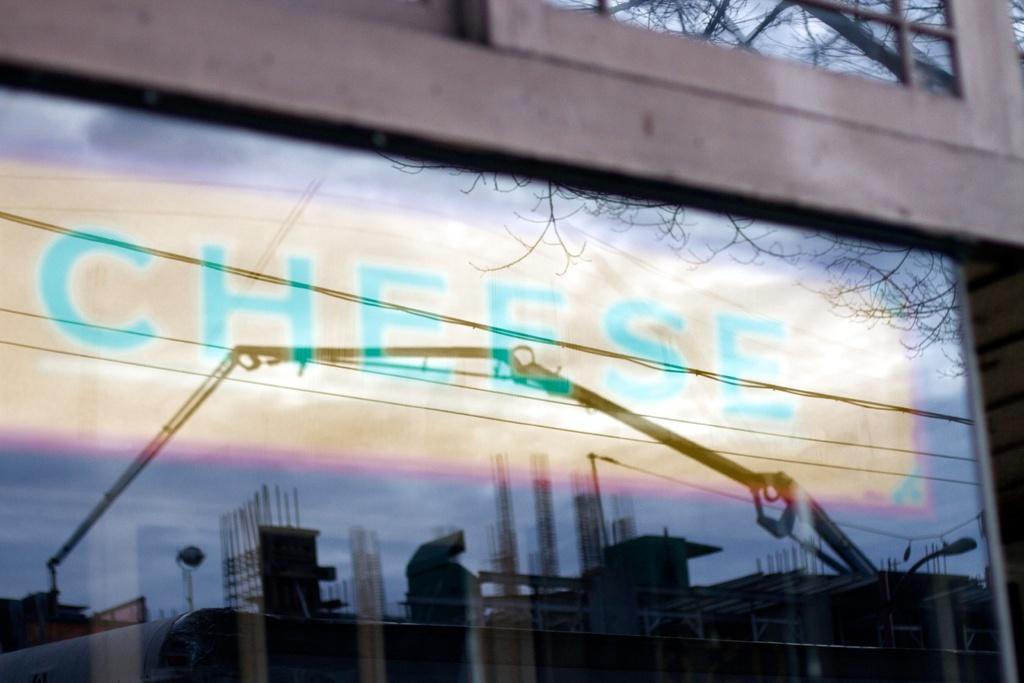Describe this image in one or two sentences. In this image in the center there is a building there are some windows, through the windows we could see some buildings, pillars, pole, light, vehicle and some text and also there are some trees. 